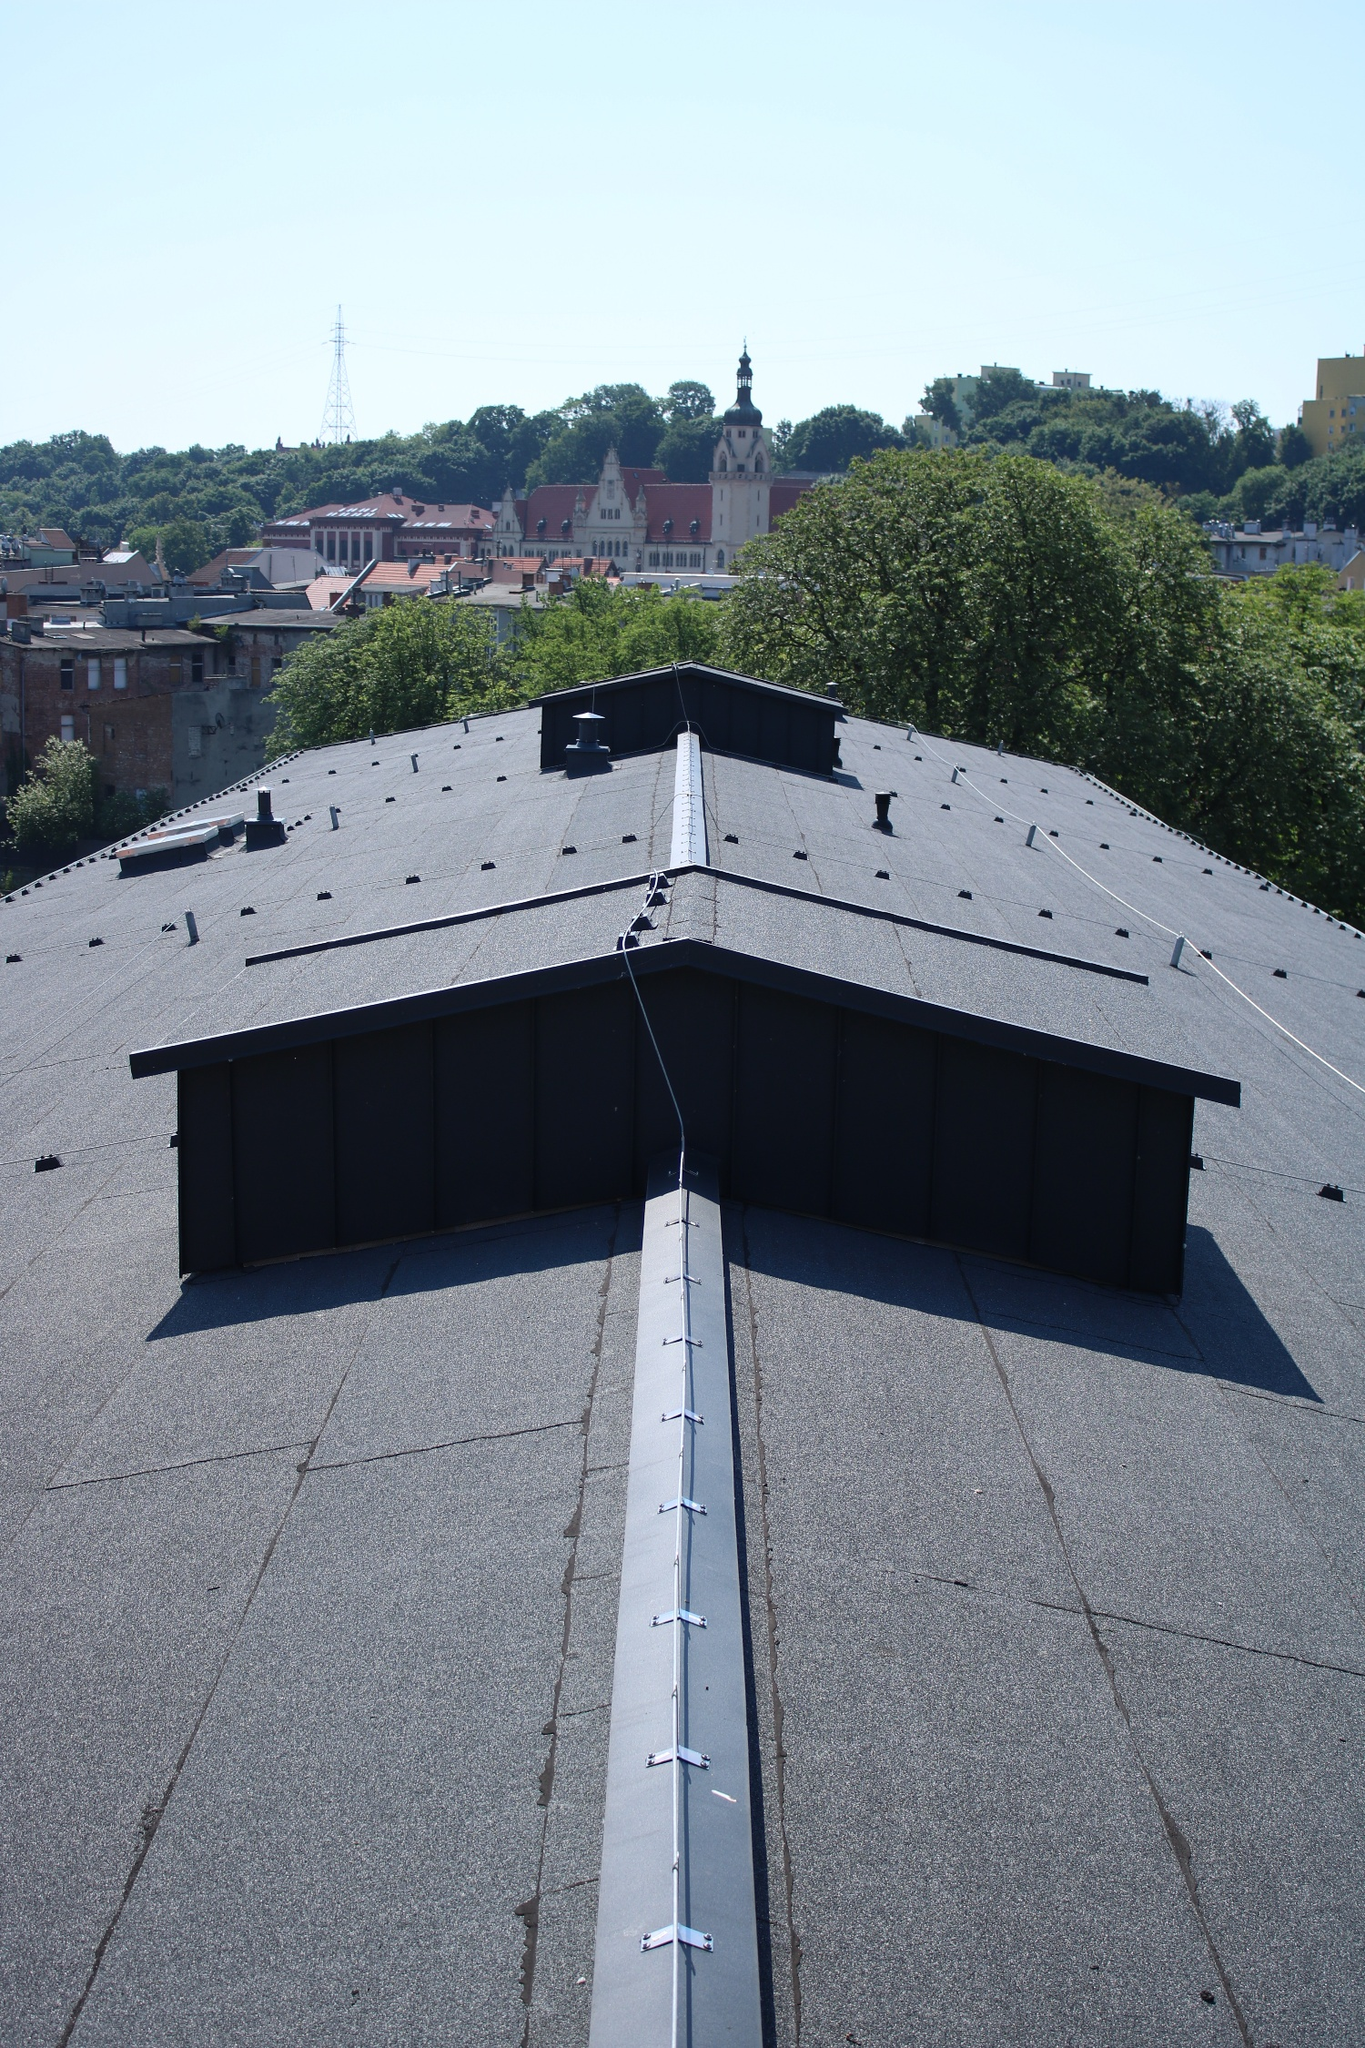Imagine this cityscape as a futuristic metropolis. How would it look? Envisioning this cityscape transformed into a futuristic metropolis, the skyline would be dominated by sleek, towering skyscrapers with reflective glass facades, reaching skyward like modern-day mountains. The rooftop in the foreground would be equipped with state-of-the-art solar panels and green terraces, creating a sustainable urban environment. Drones and flying vehicles would seamlessly traverse the air, offering a glimpse into the advanced transportation systems. Holographic advertisements and neon lights would adorn the buildings, casting a vibrant, technicolor glow over the city. Smart infrastructure, such as self-cleaning roads and adaptive buildings, would enhance the city's efficiency and resilience. The lush patches of green would evolve into vertical gardens, integrating nature within the urban fabric. Underneath the high-tech surface, the city's historical landmarks like the church-like structure would be preserved and integrated into the futuristic design, creating a harmonious blend of heritage and innovation. 